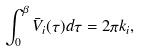Convert formula to latex. <formula><loc_0><loc_0><loc_500><loc_500>\int _ { 0 } ^ { \beta } \bar { V } _ { i } ( \tau ) d \tau = 2 \pi k _ { i } ,</formula> 